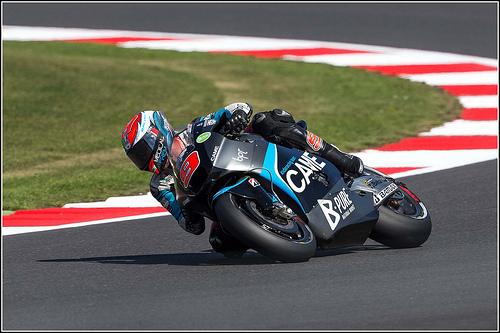What is the current state of the grass, and where is it situated? There is freshly cut green grass located in the infield of the race track. In this scene, articulate the racer's position on the motorcycle. The motorcycle racer is tilted far right, with his right knee close to the track, while maneuvering a sharp turn. Identify the type of landscape depicted in this picture. The image features an asphalt racetrack bordered by red and white stripes alongside green grass. Narrate the trajectory of the motorcycle racer on this racetrack, emphasizing their technique. The motorcycle racer is executing a tight turn, maintaining speed while skillfully leaning deeply into the curve on the racetrack. Please enumerate some notable elements found on the motorcycle in this image. The motorcycle has a black and blue frame, a blue cord on the front, thick black wheels, red number nine, white writing on the sides and bottom, and struts on the side. What is the central focus of this image, and what action is taking place? The primary focus of the image is a motorcycle racer, who is leaning tightly into a curve while riding a black and blue motorcycle with a red number on the track. Enumerate the main components seen in the foreground and background of the image. The foreground features a motorcycle racer leaned into a turn on his black and blue motorcycle with red number nine, while the background contains the asphalt racetrack, grass infield, red and white line borders, and various paint patches and signs. Analyze the racing environment, pointing out key components and their descriptions. The racing environment consists of a black paved racetrack with red and white striped borders, a green grass infield, and various colored paint patches and signs throughout. Enumerate the predominant colors present on the racer's helmet. The motorcycle rider's helmet is white, red, and blue in color. 